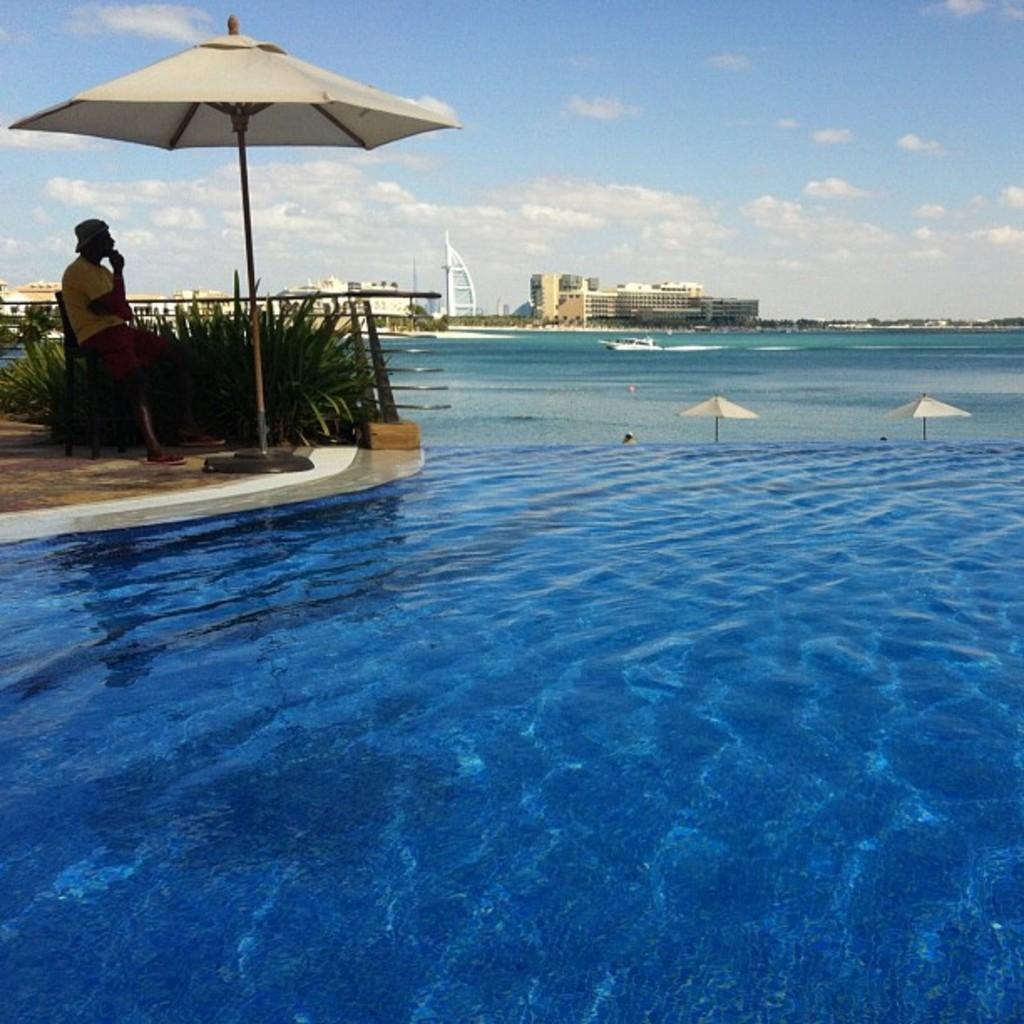How would you summarize this image in a sentence or two? This image consists of water in the middle. There is something like an umbrella on the left side. There is a person sitting on the left side. There are buildings in the middle. There is a boat in the middle. There is sky at the top. 